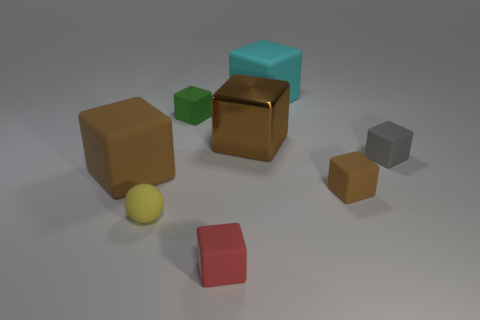Can you describe the color distribution among the objects in the image? The image features a variety of objects with different colors: there is a large brown cube, a large red cube, a small green cube, a small grey cube, and a small gold cube with a shiny surface. Additionally, there is a small yellow sphere that adds a rounded contrast to the cubic items. Are there any patterns or themes in how the objects are arranged? The objects don't appear to follow a specific pattern but are scattered naturally, with varied spacing between them. There is no clear theme to the arrangement, but the different sizes and colors lend a playful and somewhat random character to the scene, reminiscent of blocks dispersed after playtime. 